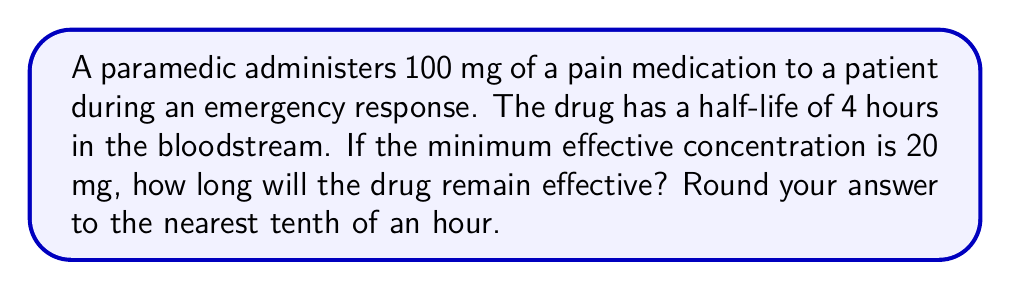Show me your answer to this math problem. Let's approach this step-by-step using an exponential decay model:

1) The exponential decay formula is:

   $$ C(t) = C_0 \cdot e^{-kt} $$

   Where:
   $C(t)$ is the concentration at time $t$
   $C_0$ is the initial concentration
   $k$ is the decay constant
   $t$ is time

2) We need to find $k$ using the half-life:

   $$ T_{1/2} = \frac{\ln(2)}{k} $$
   $$ 4 = \frac{\ln(2)}{k} $$
   $$ k = \frac{\ln(2)}{4} \approx 0.1733 $$

3) Now, we want to find $t$ when $C(t) = 20$ mg:

   $$ 20 = 100 \cdot e^{-0.1733t} $$

4) Solve for $t$:

   $$ \frac{20}{100} = e^{-0.1733t} $$
   $$ \ln(0.2) = -0.1733t $$
   $$ t = \frac{\ln(0.2)}{-0.1733} \approx 9.24 $$

5) Rounding to the nearest tenth:

   $t \approx 9.2$ hours
Answer: 9.2 hours 